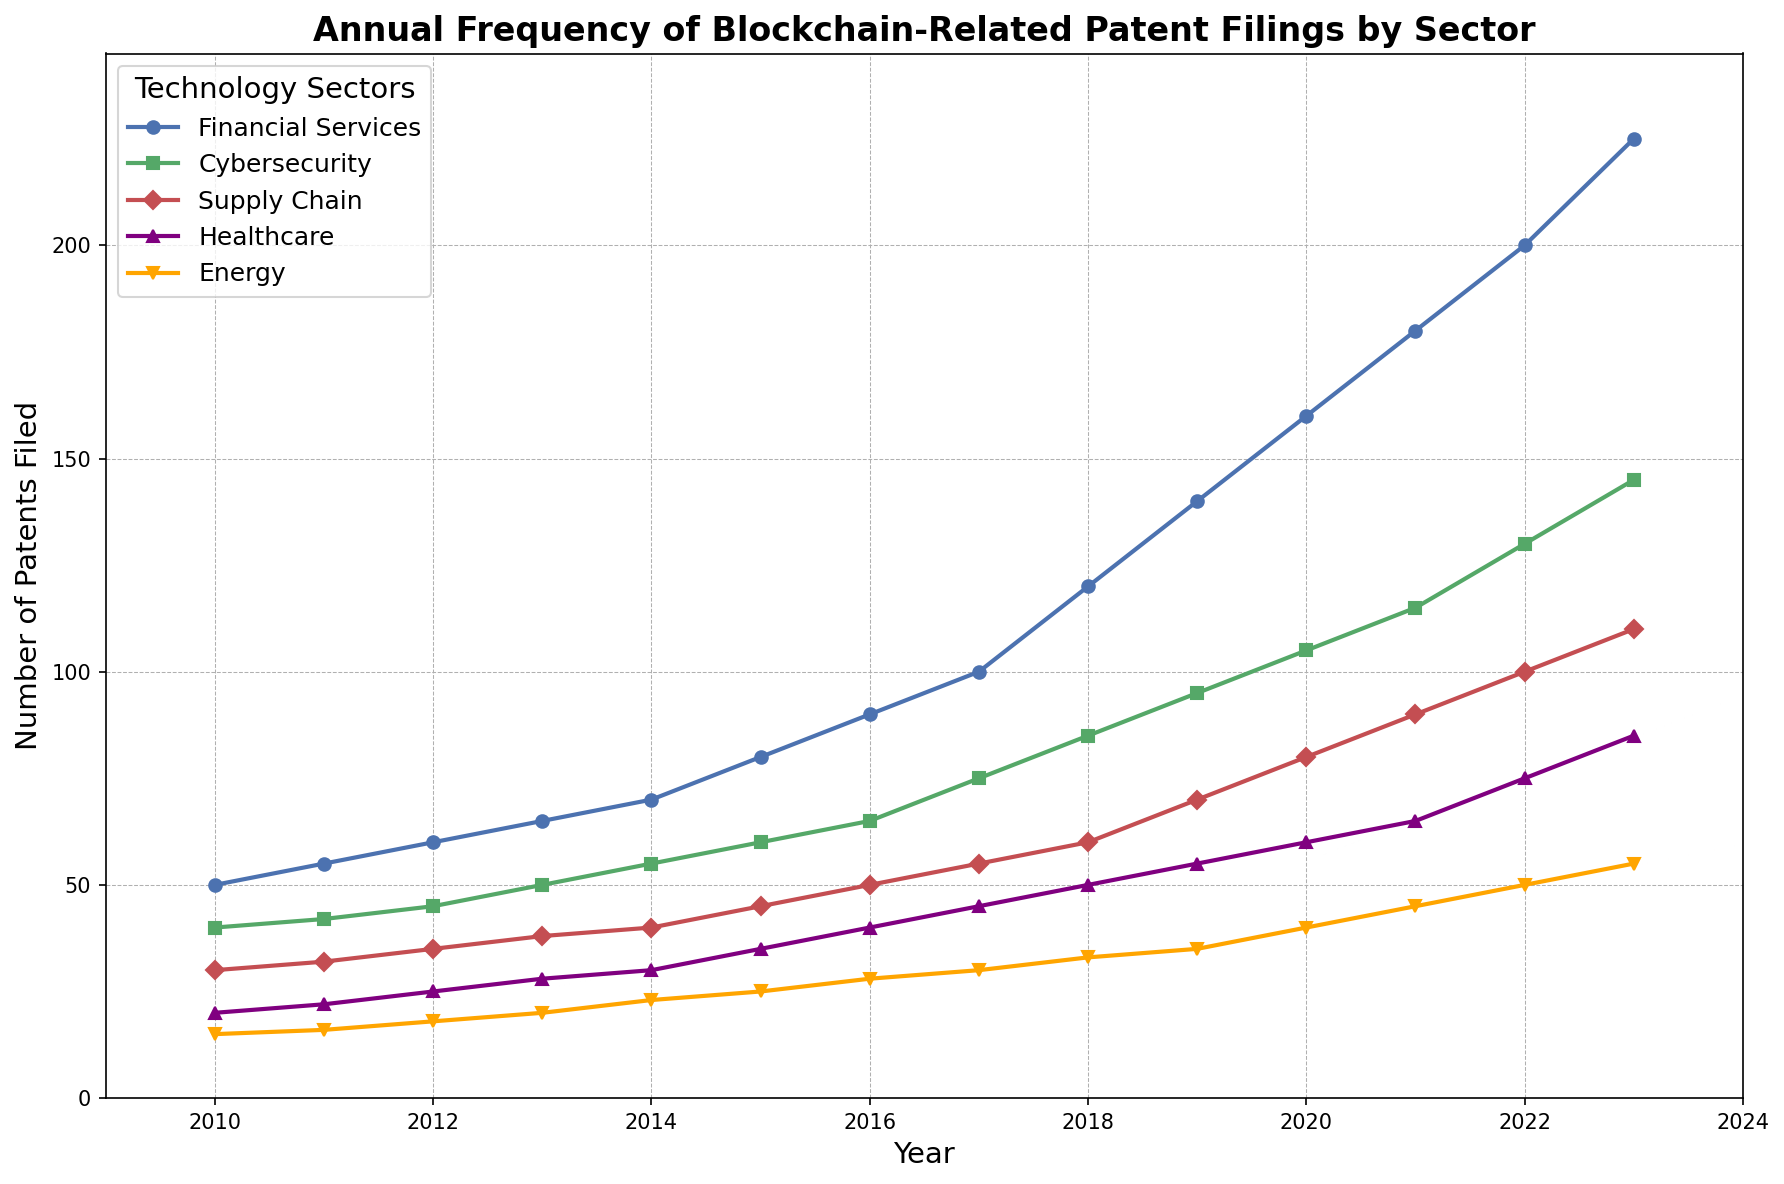Which sector has the highest number of blockchain-related patent filings in 2023? Look at the data series for 2023 across all sectors. The Financial Services sector has the highest number of patents filed at 225.
Answer: Financial Services Which sector saw the smallest increase in blockchain-related patent filings from 2010 to 2023? Calculate the difference between the 2023 and 2010 values for each sector. The Energy sector has the smallest increase, with an increase of 40 (55 - 15).
Answer: Energy What is the average number of blockchain-related patent filings in the Cybersecurity sector from 2010 to 2023? Sum all the values for the Cybersecurity sector and divide by the number of years (14). (40 + 42 + 45 + 50 + 55 + 60 + 65 + 75 + 85 + 95 + 105 + 115 + 130 + 145) / 14 = 78.21
Answer: 78.21 In which year did the Supply Chain sector surpass 50 patent filings? Identify the year in which the Supply Chain sector first has a value greater than 50. This occurs in 2019, with 70 patent filings.
Answer: 2019 Which sector has the steepest slope from 2010 to 2023 on the line chart? Evaluate the overall trend in the lines from 2010 to 2023. Financial Services has the steepest slope as it shows the largest increase, from 50 to 225.
Answer: Financial Services Which two sectors had an equal number of blockchain-related patent filings in any year? Look for the same data points across different sectors. In 2011, the Supply Chain and Cybersecurity sectors both had 32 patent filings.
Answer: Supply Chain, Cybersecurity Did any sector's number of patent filings decrease in a given year from 2010 to 2023? Check the trend for each sector year by year. All sectors have shown a consistent increase; none of them decreased in any year.
Answer: No What is the combined number of patent filings across all sectors in 2020? Sum the 2020 values for all the sectors: Financial Services (160) + Cybersecurity (105) + Supply Chain (80) + Healthcare (60) + Energy (40) = 445.
Answer: 445 Between Healthcare and Energy sectors, which one had more rapid growth in the number of patent filings from 2015 to 2020? Calculate the increase for both sectors from 2015 to 2020. Healthcare increased from 35 to 60 (25) and Energy from 25 to 40 (15). Hence, the Healthcare sector had more rapid growth.
Answer: Healthcare How many years did it take for Financial Services to double its number of patent filings from its 2010 value? Find the year when Financial Services filings are twice 2010's value (50 * 2 = 100). This occurs in 2017, so it took 7 years.
Answer: 7 